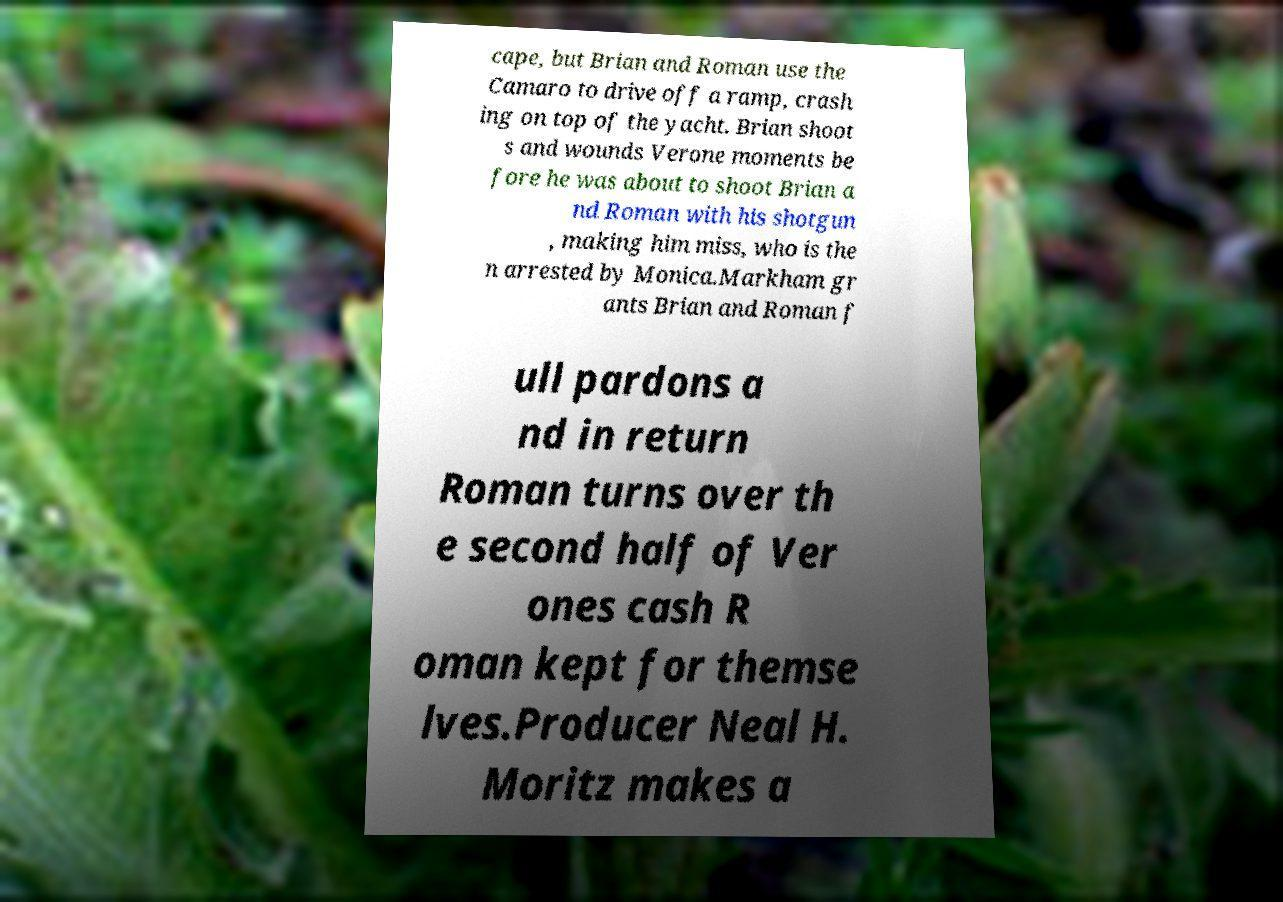Please identify and transcribe the text found in this image. cape, but Brian and Roman use the Camaro to drive off a ramp, crash ing on top of the yacht. Brian shoot s and wounds Verone moments be fore he was about to shoot Brian a nd Roman with his shotgun , making him miss, who is the n arrested by Monica.Markham gr ants Brian and Roman f ull pardons a nd in return Roman turns over th e second half of Ver ones cash R oman kept for themse lves.Producer Neal H. Moritz makes a 